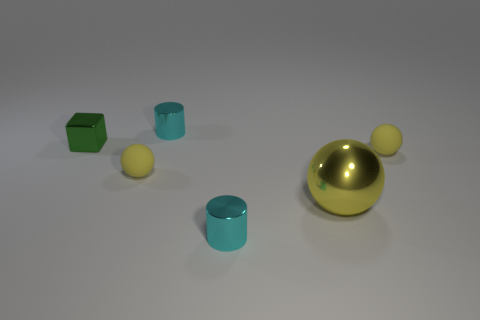Add 2 yellow shiny objects. How many objects exist? 8 Subtract all cylinders. How many objects are left? 4 Subtract all big yellow shiny balls. Subtract all small cylinders. How many objects are left? 3 Add 5 large yellow things. How many large yellow things are left? 6 Add 2 big balls. How many big balls exist? 3 Subtract 0 brown balls. How many objects are left? 6 